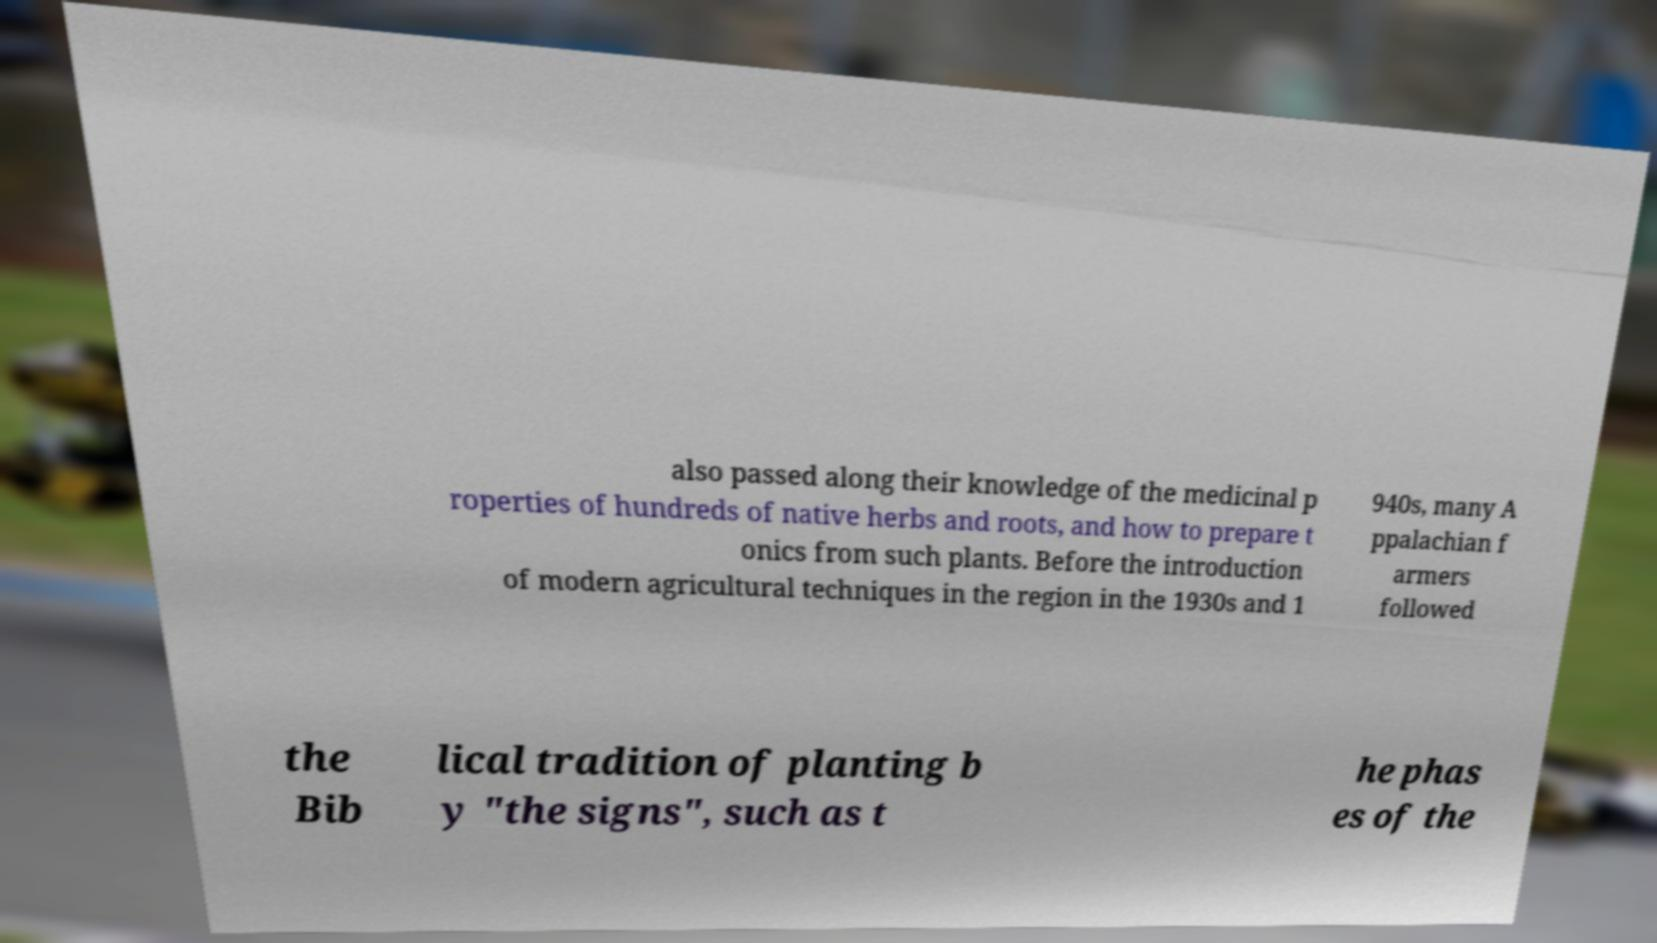Can you read and provide the text displayed in the image?This photo seems to have some interesting text. Can you extract and type it out for me? also passed along their knowledge of the medicinal p roperties of hundreds of native herbs and roots, and how to prepare t onics from such plants. Before the introduction of modern agricultural techniques in the region in the 1930s and 1 940s, many A ppalachian f armers followed the Bib lical tradition of planting b y "the signs", such as t he phas es of the 